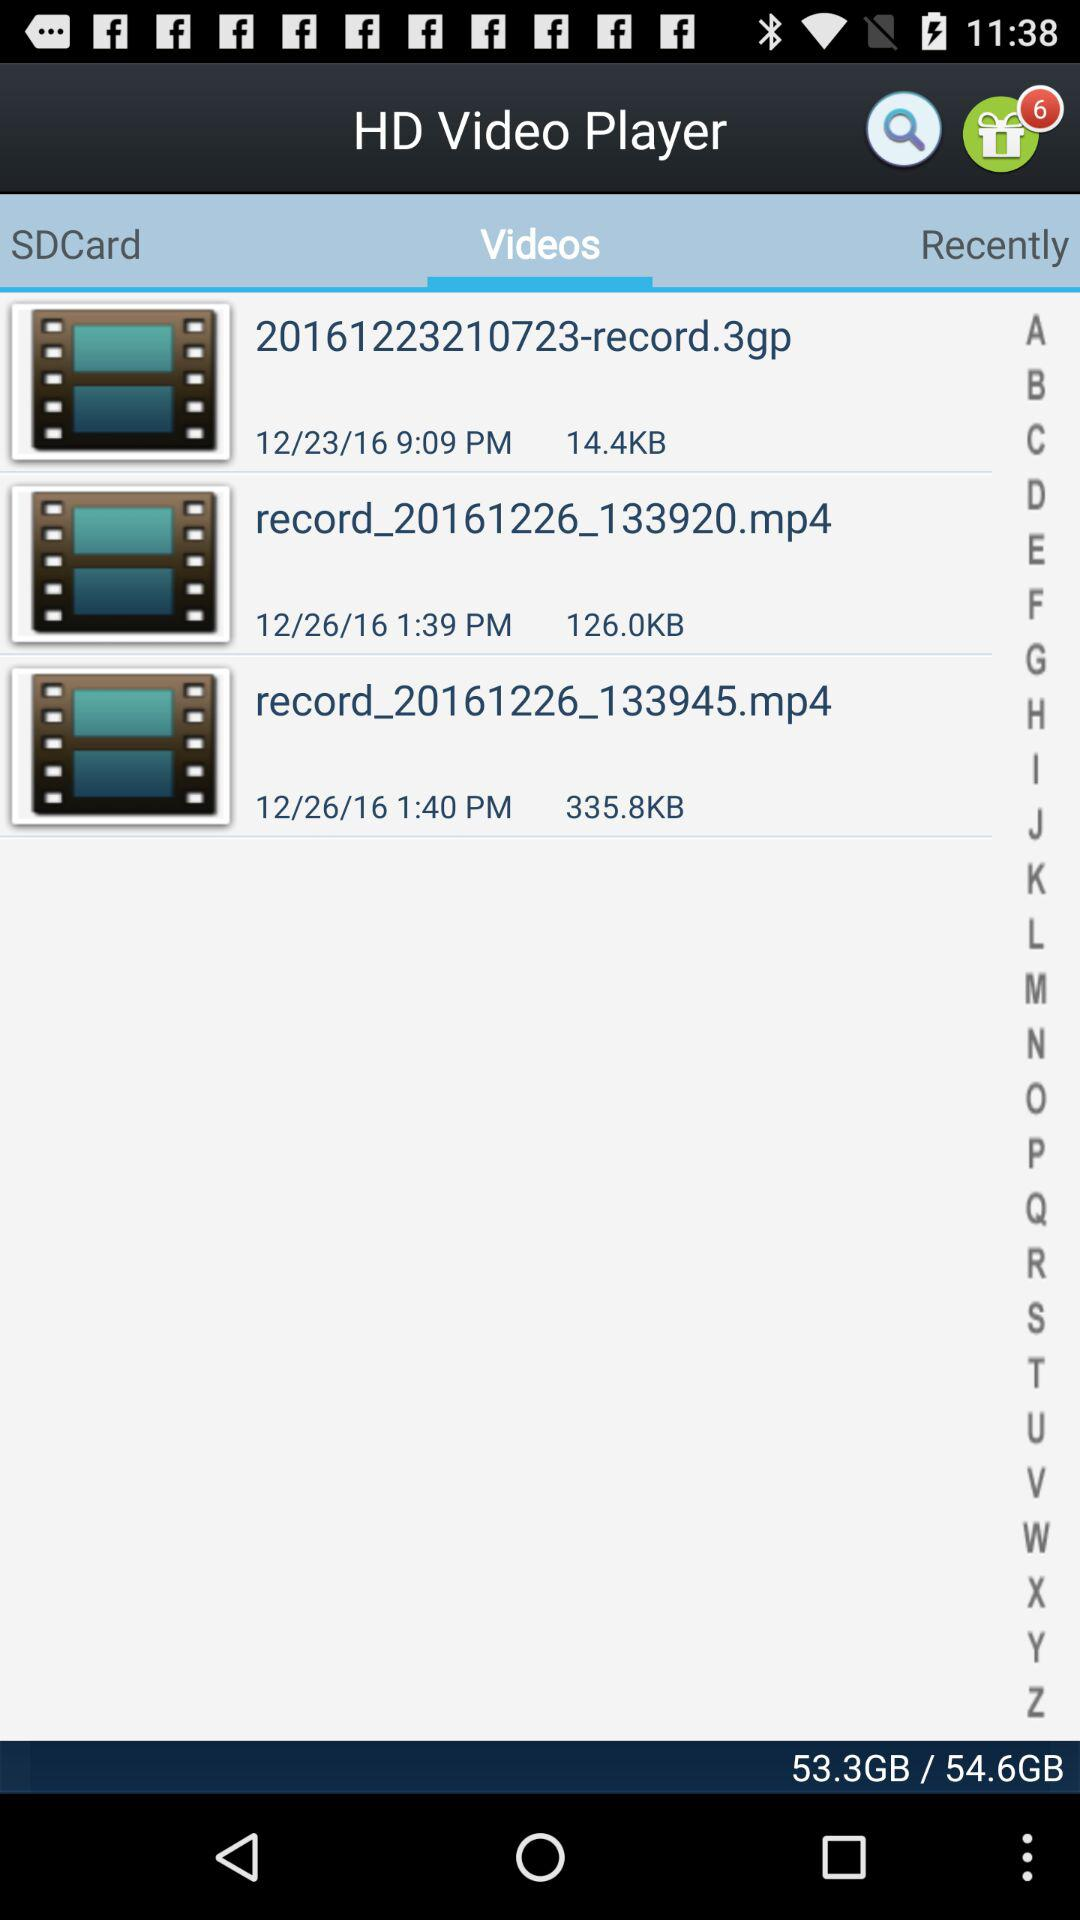How many videos are there in the SDCard folder?
Answer the question using a single word or phrase. 3 